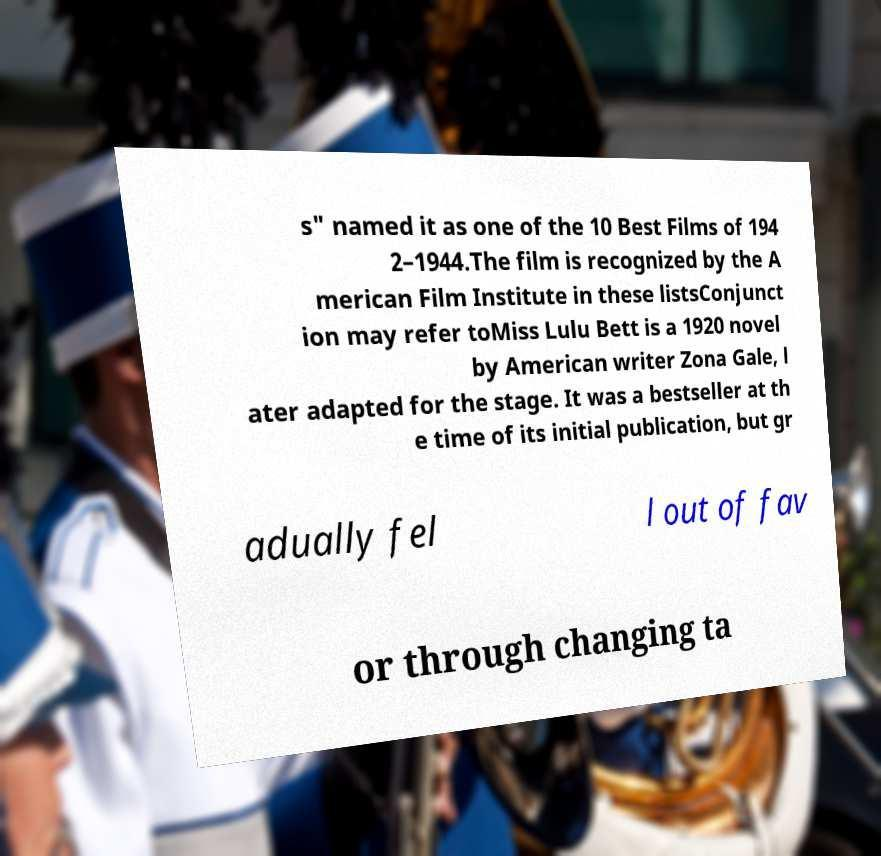I need the written content from this picture converted into text. Can you do that? s" named it as one of the 10 Best Films of 194 2–1944.The film is recognized by the A merican Film Institute in these listsConjunct ion may refer toMiss Lulu Bett is a 1920 novel by American writer Zona Gale, l ater adapted for the stage. It was a bestseller at th e time of its initial publication, but gr adually fel l out of fav or through changing ta 